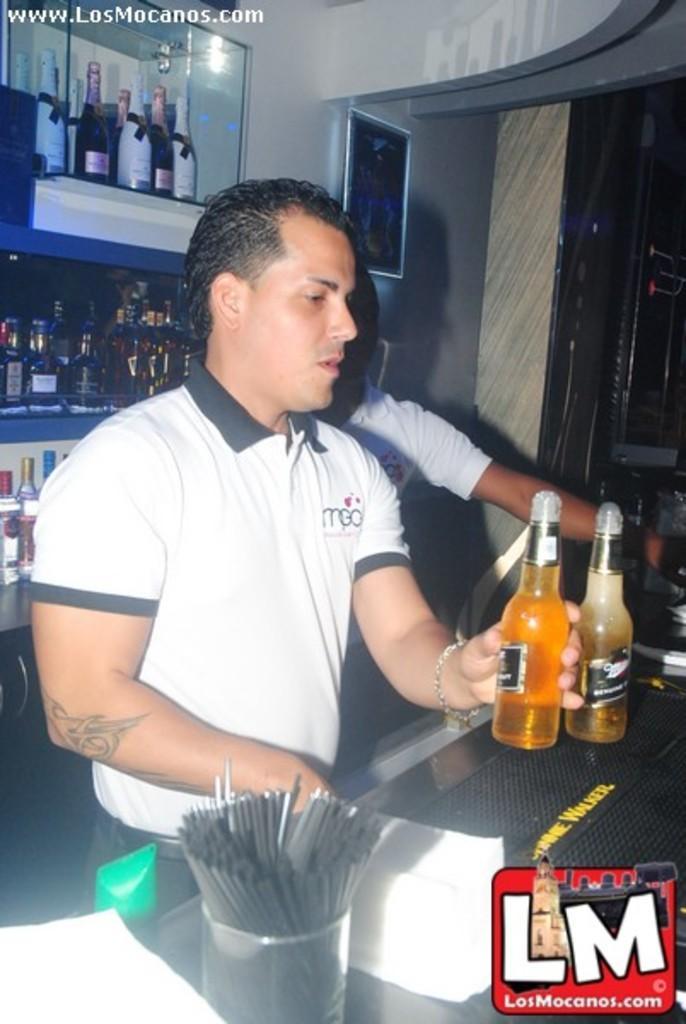How would you summarize this image in a sentence or two? This is a guy holding a bottle of beer, behind him there is a man standing, behind both of them there is a rack which consists of champagne,wines and beers 